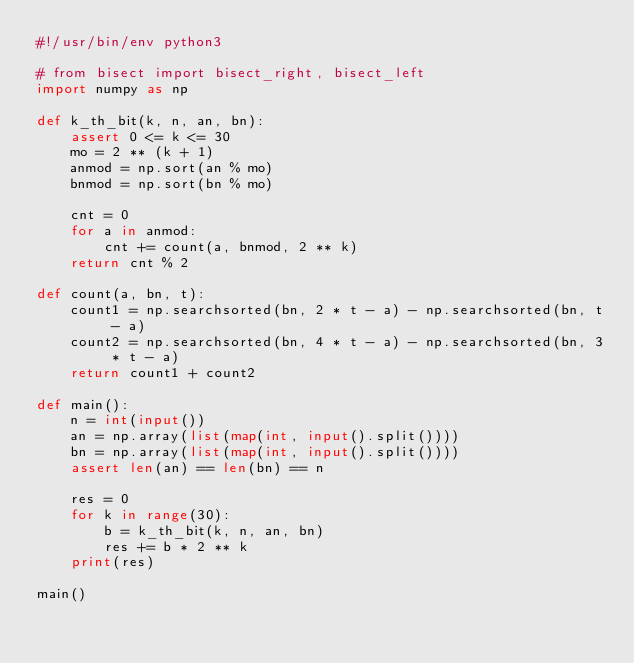<code> <loc_0><loc_0><loc_500><loc_500><_Python_>#!/usr/bin/env python3

# from bisect import bisect_right, bisect_left
import numpy as np

def k_th_bit(k, n, an, bn):
    assert 0 <= k <= 30
    mo = 2 ** (k + 1)
    anmod = np.sort(an % mo)
    bnmod = np.sort(bn % mo)

    cnt = 0
    for a in anmod:
        cnt += count(a, bnmod, 2 ** k)
    return cnt % 2

def count(a, bn, t):
    count1 = np.searchsorted(bn, 2 * t - a) - np.searchsorted(bn, t - a)
    count2 = np.searchsorted(bn, 4 * t - a) - np.searchsorted(bn, 3 * t - a)
    return count1 + count2

def main():
    n = int(input())
    an = np.array(list(map(int, input().split())))
    bn = np.array(list(map(int, input().split())))
    assert len(an) == len(bn) == n

    res = 0
    for k in range(30):
        b = k_th_bit(k, n, an, bn)
        res += b * 2 ** k
    print(res)

main()
</code> 